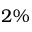Convert formula to latex. <formula><loc_0><loc_0><loc_500><loc_500>2 \%</formula> 